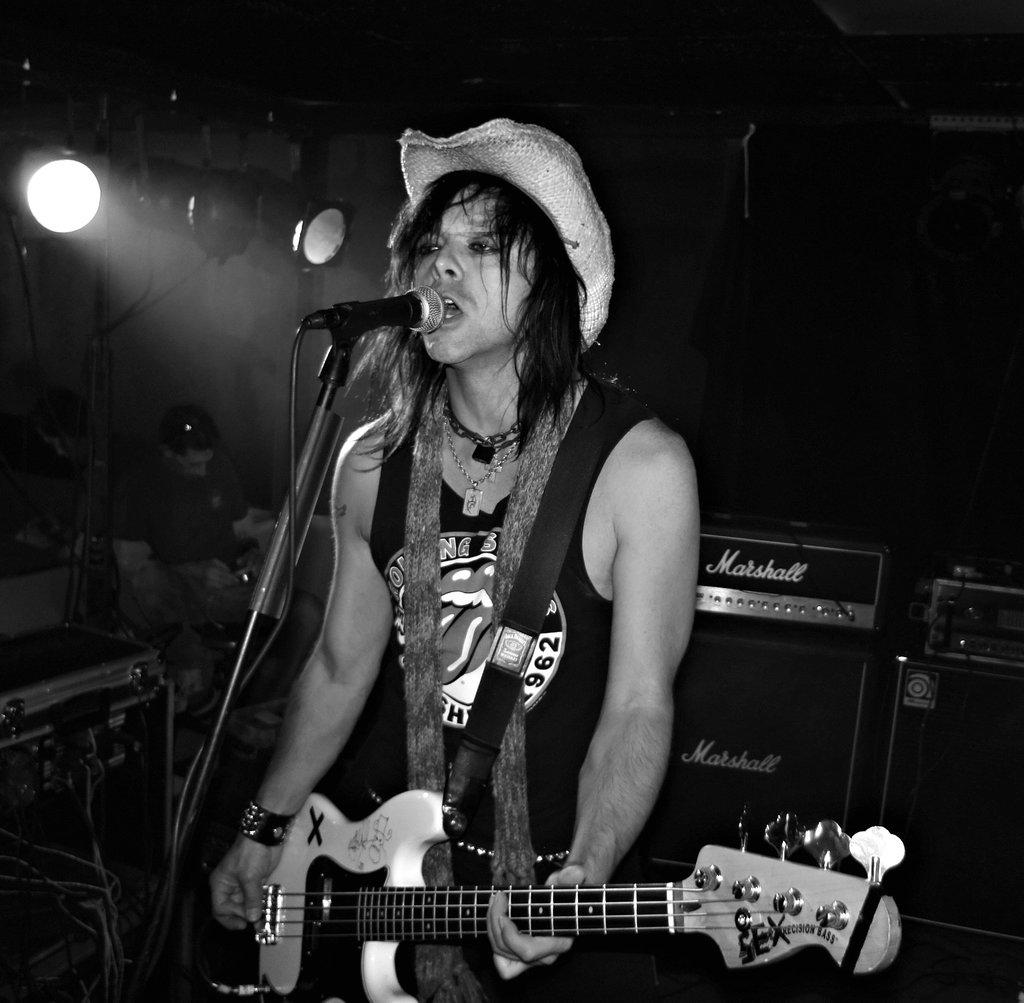What is the main subject of the image? There is a person in the image. What is the person doing in the image? The person is standing in front of a microphone and holding a guitar. What is the person wearing on their head? The person is wearing a hat. What can be seen in the background of the image? There are people sitting in the background. What is the lighting condition in the image? There is light in the image. What time of day is it in the person's bedroom, as depicted in the image? The image does not show a bedroom, and therefore it is not possible to determine the time of day in the person's bedroom. 